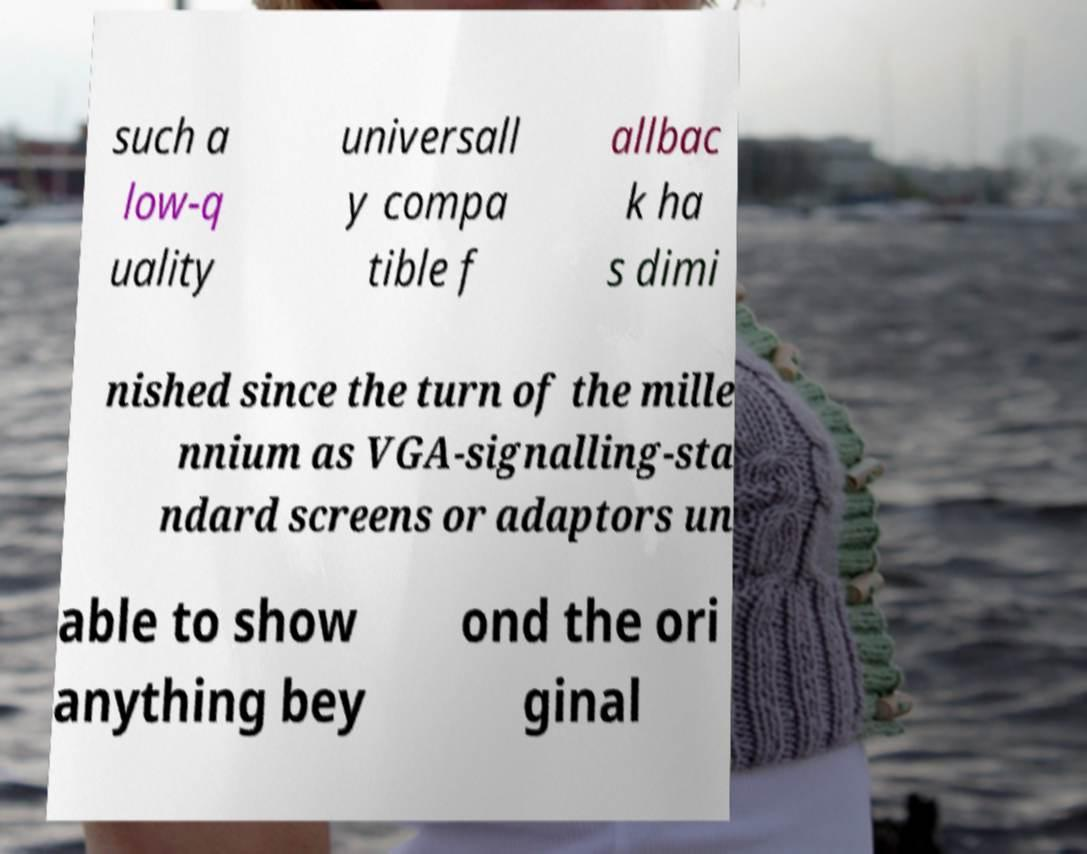For documentation purposes, I need the text within this image transcribed. Could you provide that? such a low-q uality universall y compa tible f allbac k ha s dimi nished since the turn of the mille nnium as VGA-signalling-sta ndard screens or adaptors un able to show anything bey ond the ori ginal 